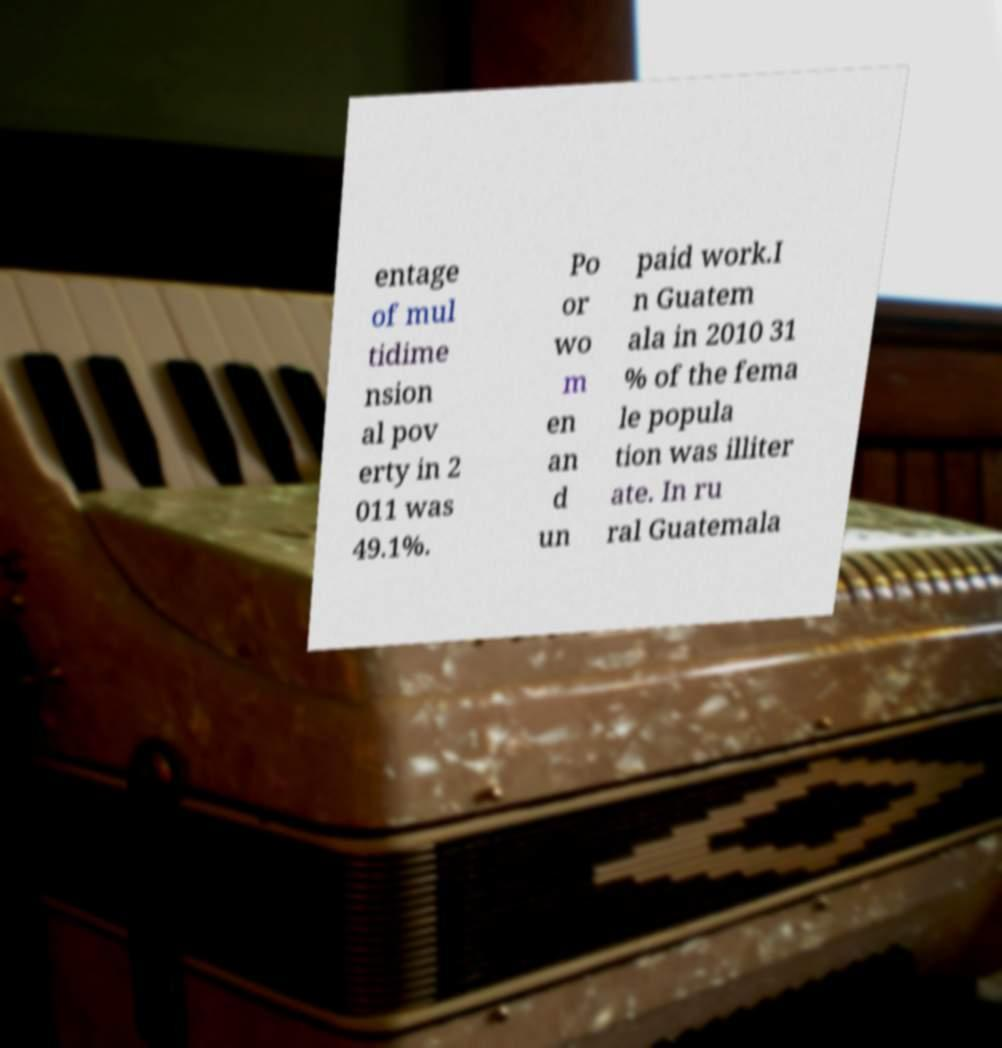Can you accurately transcribe the text from the provided image for me? entage of mul tidime nsion al pov erty in 2 011 was 49.1%. Po or wo m en an d un paid work.I n Guatem ala in 2010 31 % of the fema le popula tion was illiter ate. In ru ral Guatemala 